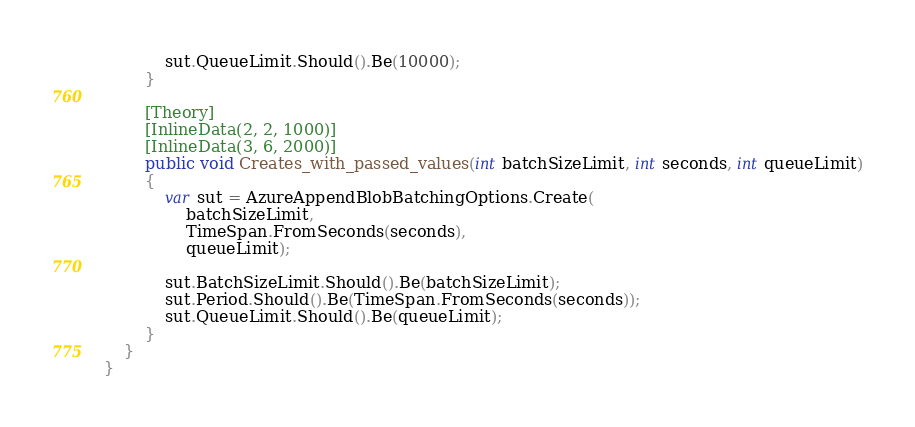<code> <loc_0><loc_0><loc_500><loc_500><_C#_>            sut.QueueLimit.Should().Be(10000);
        }

        [Theory]
        [InlineData(2, 2, 1000)]
        [InlineData(3, 6, 2000)]
        public void Creates_with_passed_values(int batchSizeLimit, int seconds, int queueLimit)
        {
            var sut = AzureAppendBlobBatchingOptions.Create(
                batchSizeLimit,
                TimeSpan.FromSeconds(seconds),
                queueLimit);

            sut.BatchSizeLimit.Should().Be(batchSizeLimit);
            sut.Period.Should().Be(TimeSpan.FromSeconds(seconds));
            sut.QueueLimit.Should().Be(queueLimit);
        }
    }
}</code> 